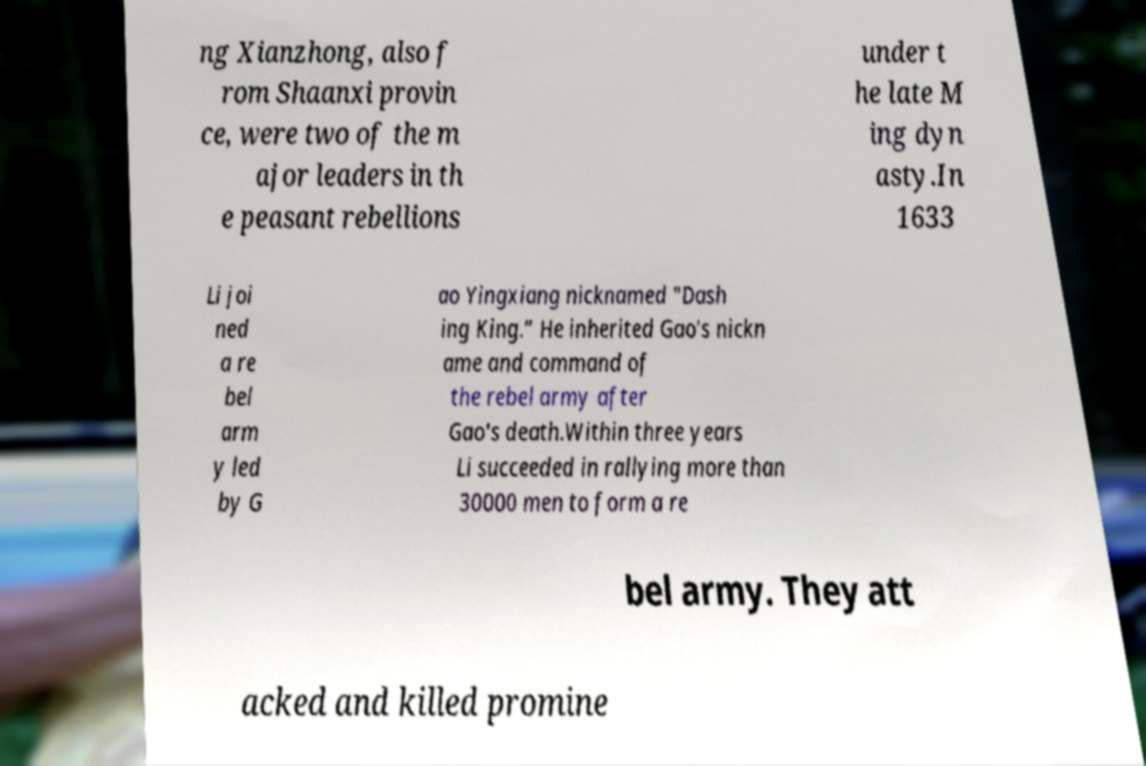For documentation purposes, I need the text within this image transcribed. Could you provide that? ng Xianzhong, also f rom Shaanxi provin ce, were two of the m ajor leaders in th e peasant rebellions under t he late M ing dyn asty.In 1633 Li joi ned a re bel arm y led by G ao Yingxiang nicknamed "Dash ing King.” He inherited Gao's nickn ame and command of the rebel army after Gao's death.Within three years Li succeeded in rallying more than 30000 men to form a re bel army. They att acked and killed promine 